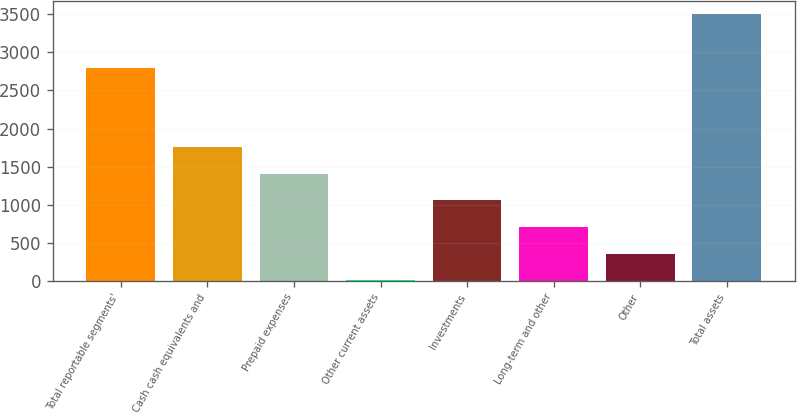Convert chart to OTSL. <chart><loc_0><loc_0><loc_500><loc_500><bar_chart><fcel>Total reportable segments'<fcel>Cash cash equivalents and<fcel>Prepaid expenses<fcel>Other current assets<fcel>Investments<fcel>Long-term and other<fcel>Other<fcel>Total assets<nl><fcel>2796<fcel>1755<fcel>1404.4<fcel>2<fcel>1053.8<fcel>703.2<fcel>352.6<fcel>3508<nl></chart> 